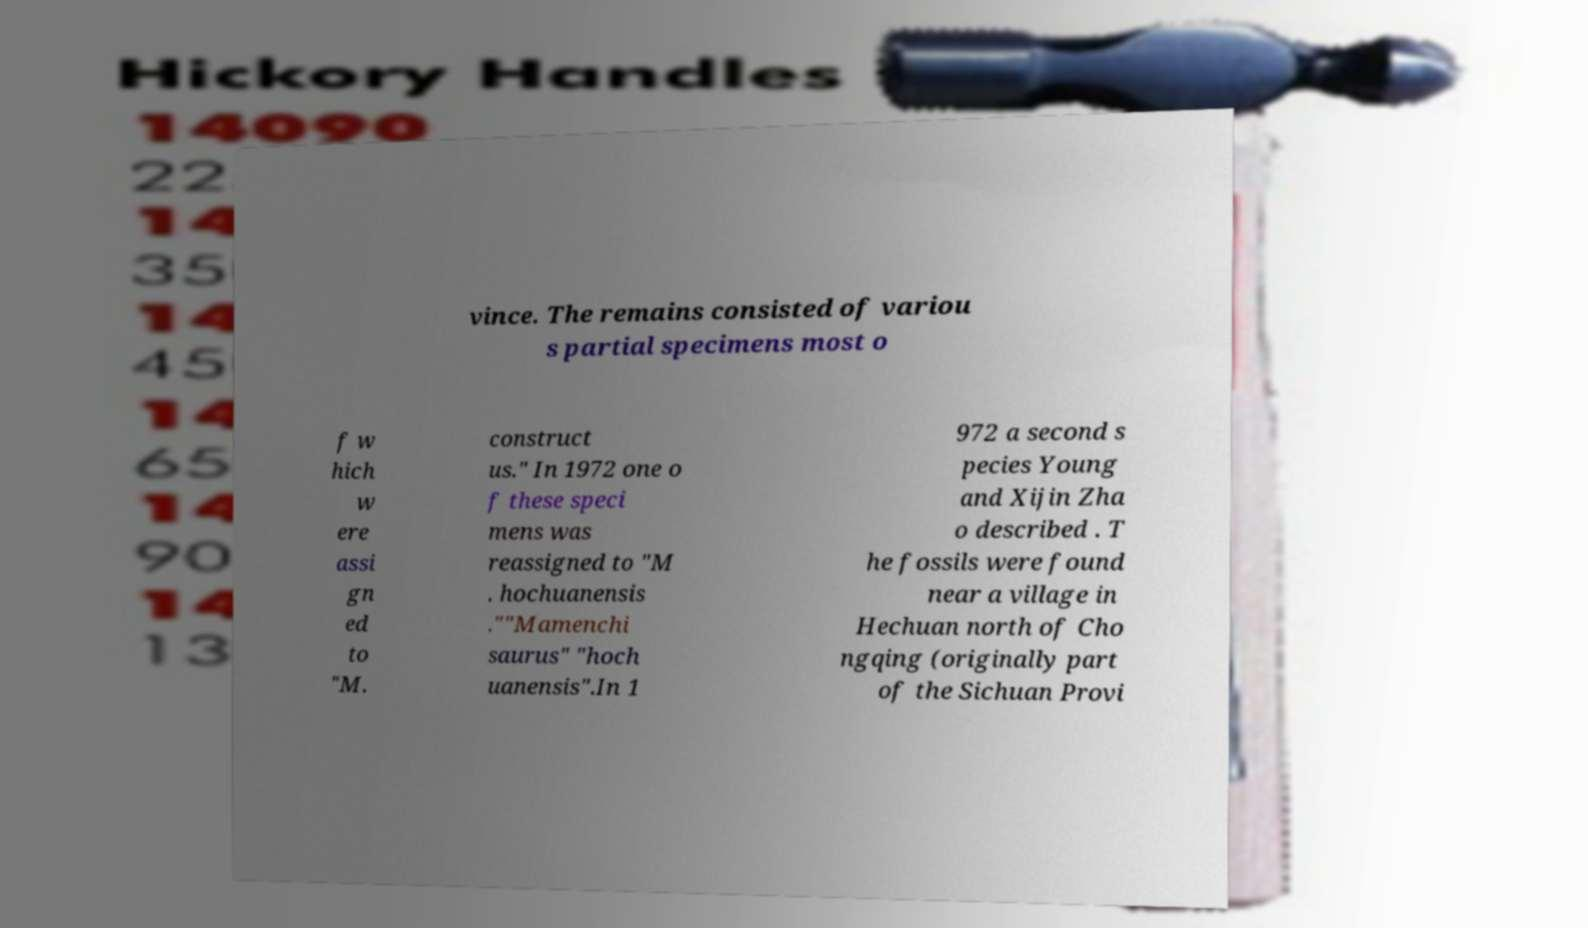There's text embedded in this image that I need extracted. Can you transcribe it verbatim? vince. The remains consisted of variou s partial specimens most o f w hich w ere assi gn ed to "M. construct us." In 1972 one o f these speci mens was reassigned to "M . hochuanensis .""Mamenchi saurus" "hoch uanensis".In 1 972 a second s pecies Young and Xijin Zha o described . T he fossils were found near a village in Hechuan north of Cho ngqing (originally part of the Sichuan Provi 